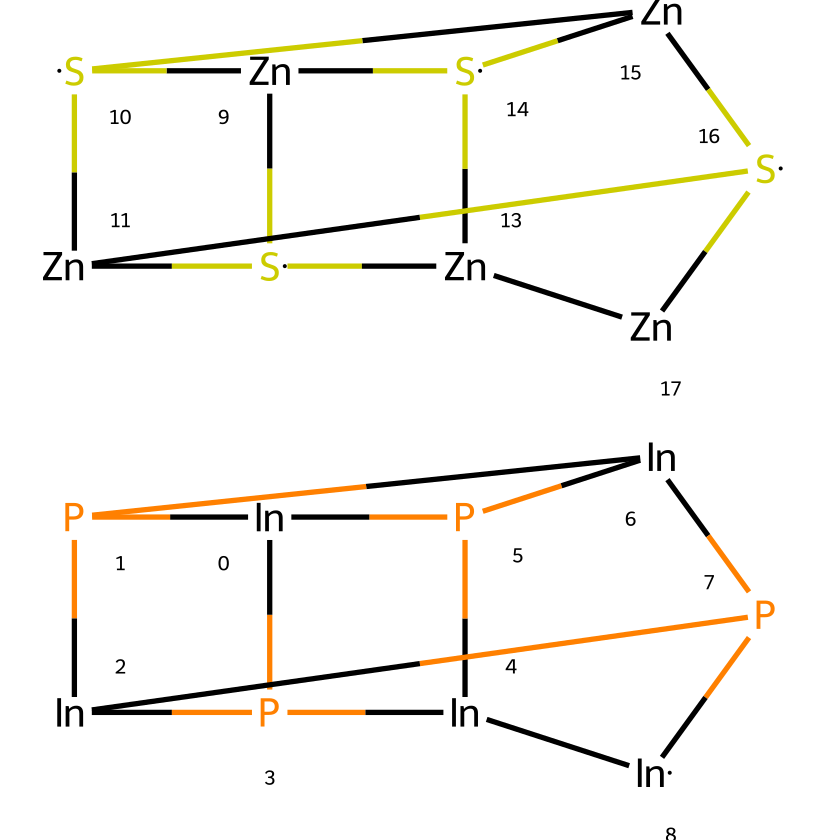What elements are present in this quantum dot? The SMILES representation indicates the presence of indium (In), phosphorus (P), zinc (Zn), and sulfur (S) atoms.
Answer: indium, phosphorus, zinc, sulfur How many indium atoms are there in the structure? By analyzing the SMILES string, we see that there are five instances of [In], which indicates the presence of five indium atoms in the core structure.
Answer: five What is the core composition of this quantum dot? The chemical structure starts with indium and phosphorus, which forms the core; thus, it can be identified as an indium phosphide core.
Answer: indium phosphide What is the shell composition around the core? The outer part of the SMILES starts with [Zn] and ends with [S], indicating that the shell is composed of zinc and sulfur; hence it can be described as zinc sulfide.
Answer: zinc sulfide Which atoms are involved in the core-shell structure? The core-shell structure consists of indium and phosphorus in the core, and zinc and sulfur in the shell.
Answer: indium, phosphorus, zinc, sulfur What type of quantum dot structure is represented here? This chemical structure represents a core-shell quantum dot, where indium phosphide serves as the core and zinc sulfide acts as the shell.
Answer: core-shell quantum dot Explain the significance of having a core-shell structure in quantum dots. The core-shell design can enhance the optical properties and stability of the quantum dot, improving its performance in applications such as imaging and sensing.
Answer: enhances optical properties and stability 